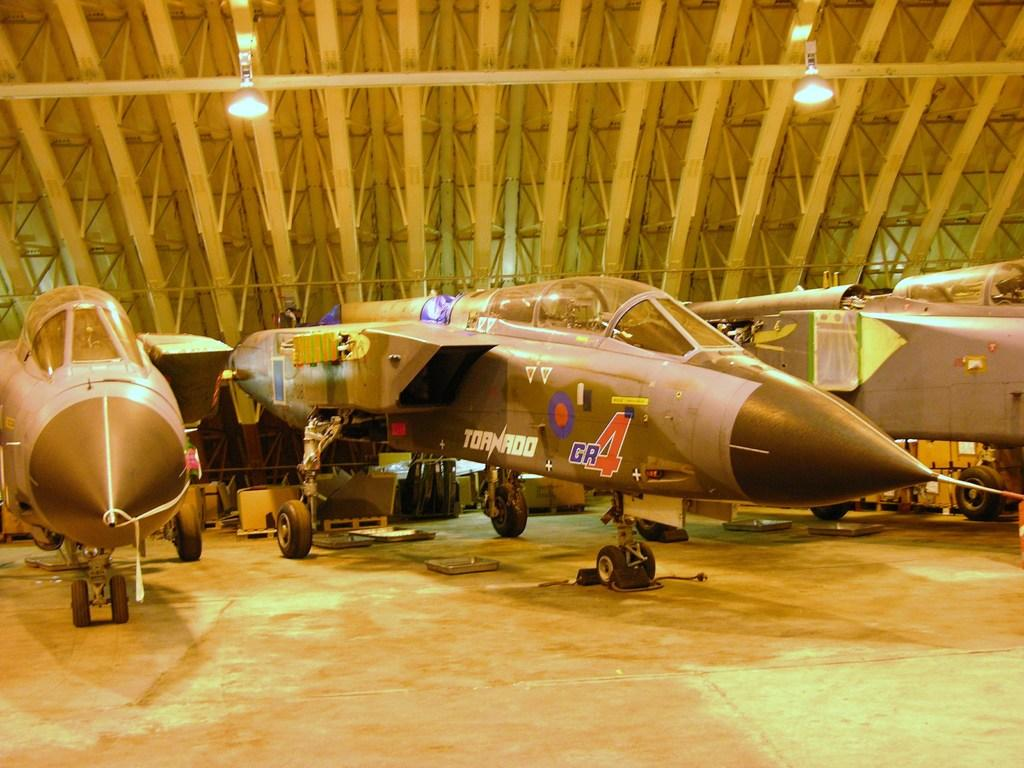<image>
Relay a brief, clear account of the picture shown. A military fighter plane is labeled on its side with the word Tornado. 